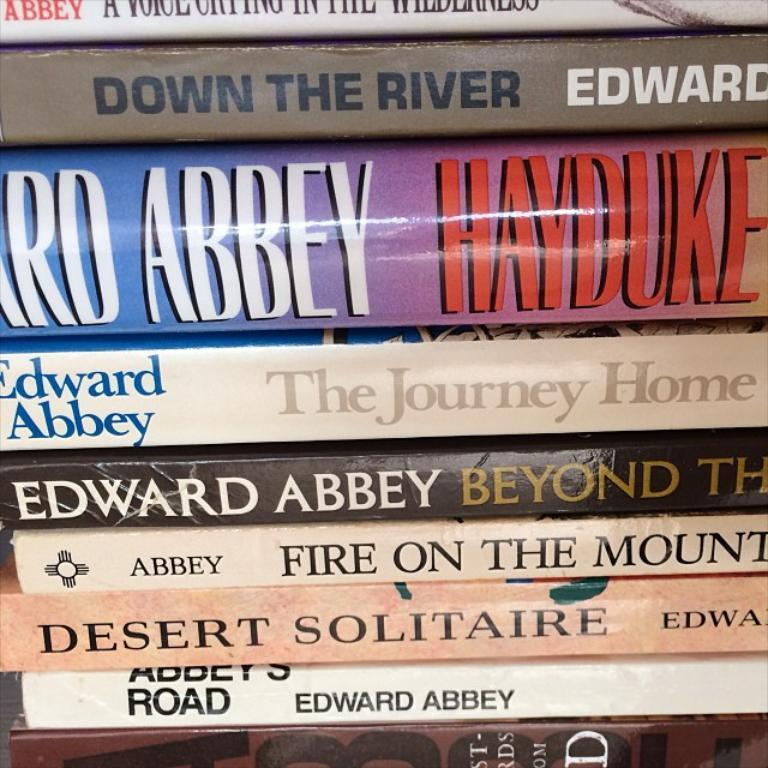<image>
Summarize the visual content of the image. the name Edward Abbey is on a couple books 